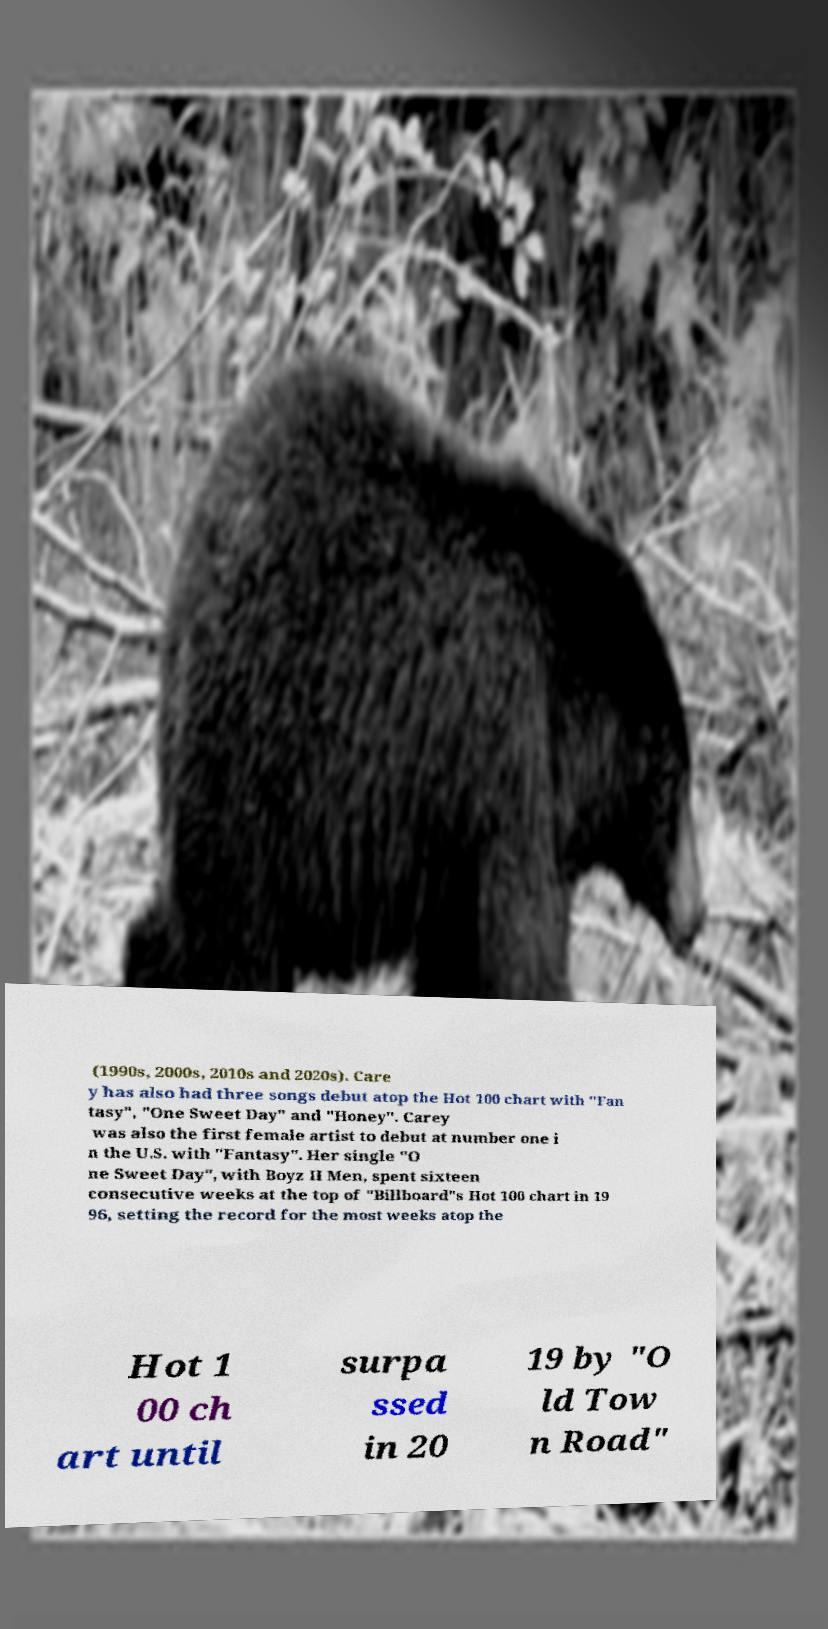Can you read and provide the text displayed in the image?This photo seems to have some interesting text. Can you extract and type it out for me? (1990s, 2000s, 2010s and 2020s). Care y has also had three songs debut atop the Hot 100 chart with "Fan tasy", "One Sweet Day" and "Honey". Carey was also the first female artist to debut at number one i n the U.S. with "Fantasy". Her single "O ne Sweet Day", with Boyz II Men, spent sixteen consecutive weeks at the top of "Billboard"s Hot 100 chart in 19 96, setting the record for the most weeks atop the Hot 1 00 ch art until surpa ssed in 20 19 by "O ld Tow n Road" 